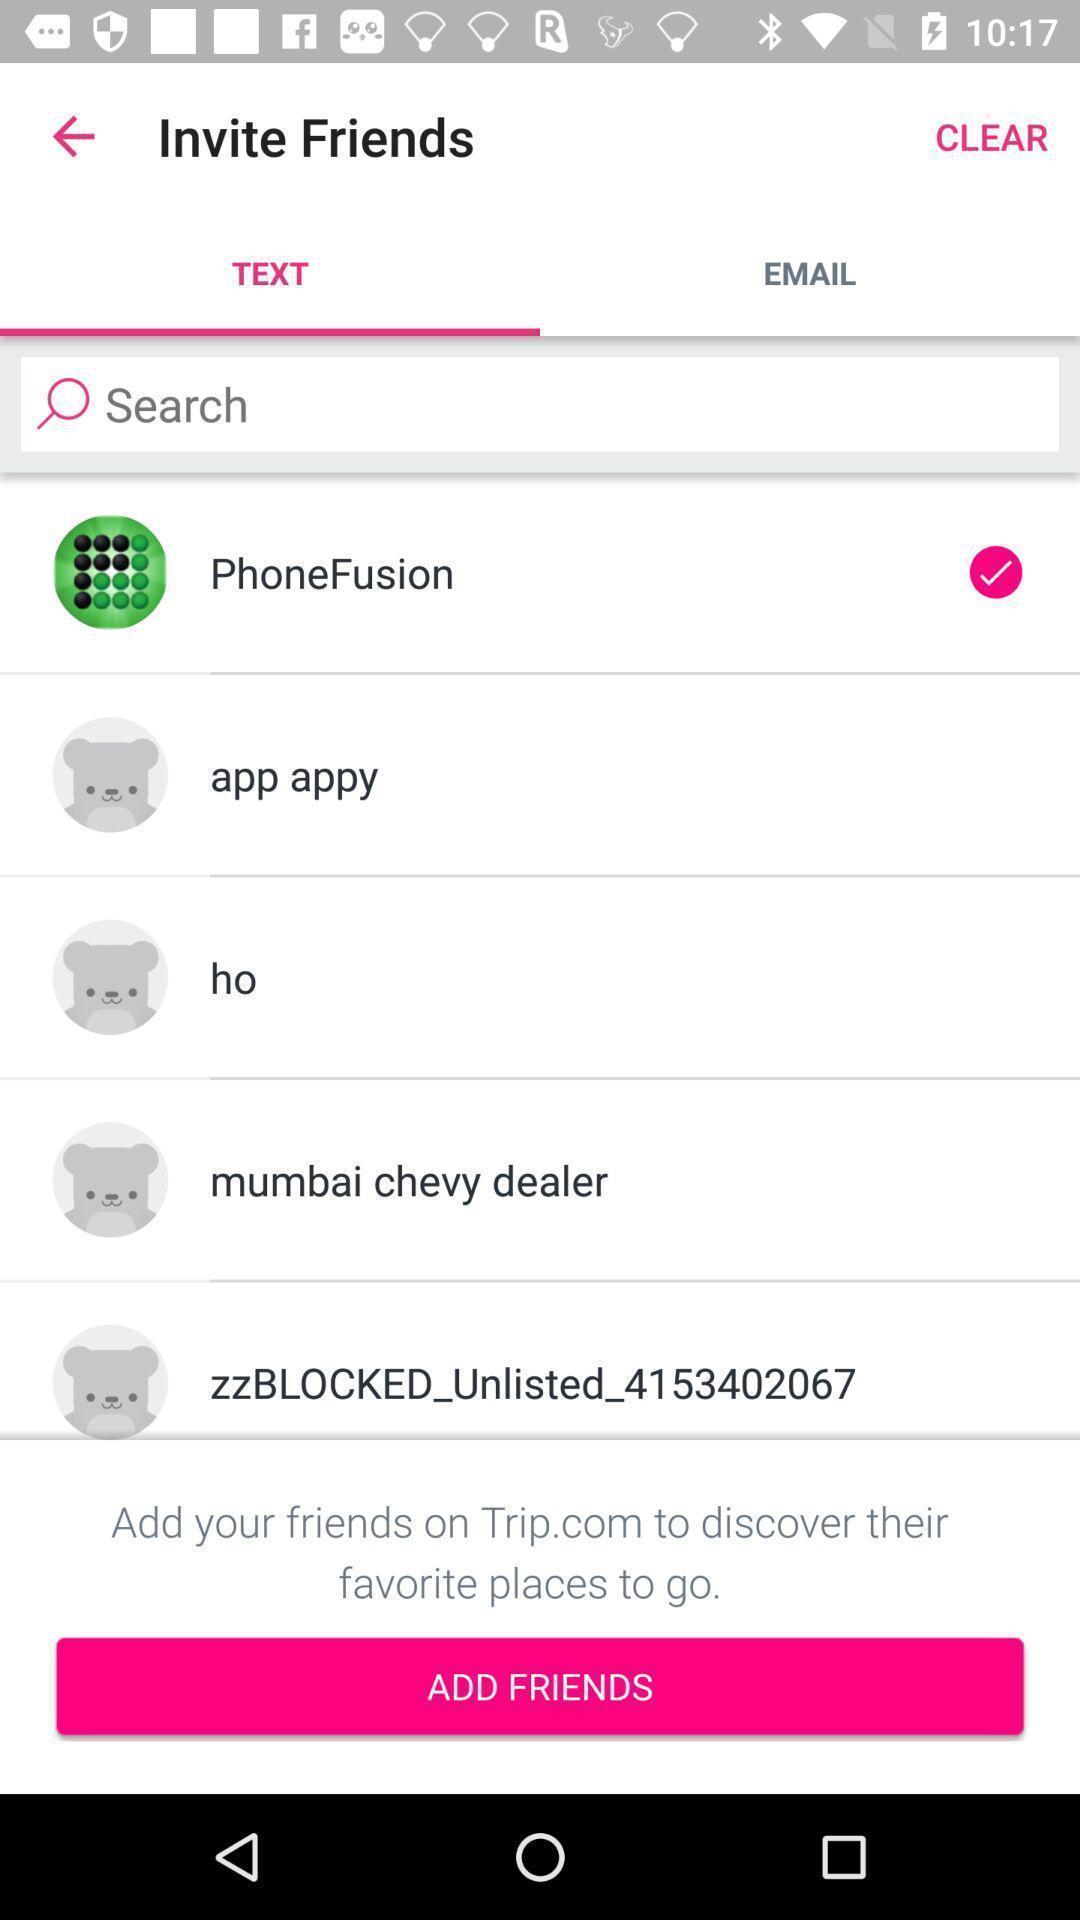Give me a summary of this screen capture. Page showing contacts to invite on a travel app. 